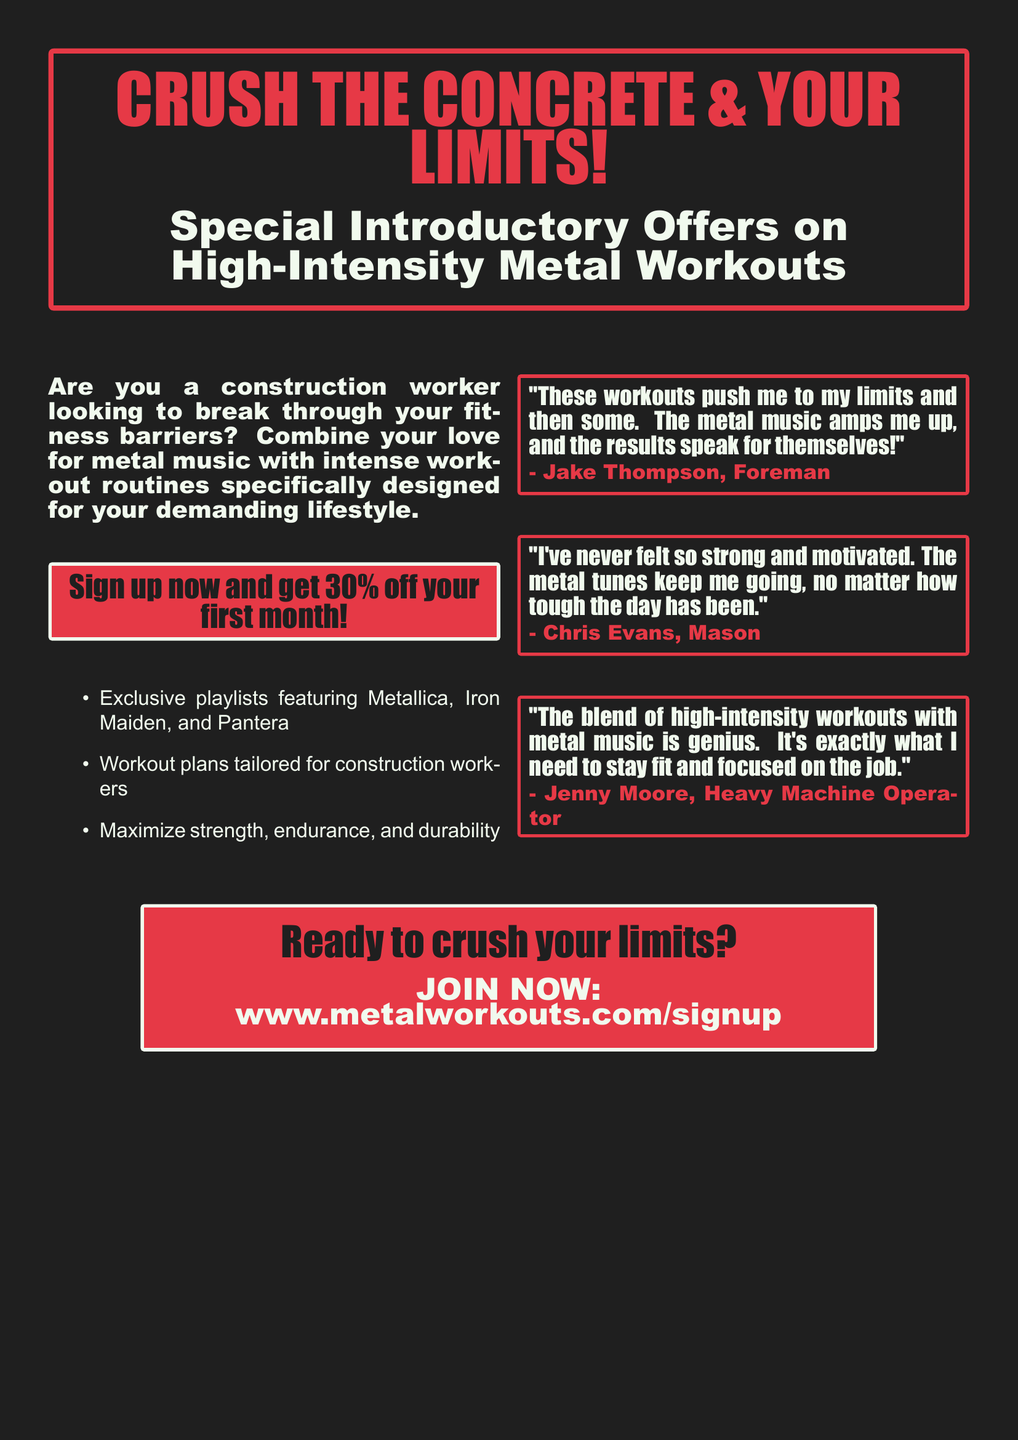What is the discount offered on the first month? The document states that signing up now gets you 30% off your first month.
Answer: 30% Who is the target audience for these workouts? The advertisement mentions construction workers specifically as the audience for the workouts.
Answer: Construction workers Which band is mentioned as part of the exclusive playlists? The document lists Metallica among the bands featured in the playlists.
Answer: Metallica What is the website for sign-up? The advertisement provides the sign-up URL as www.metalworkouts.com/signup.
Answer: www.metalworkouts.com/signup What type of workouts are offered according to the document? The document describes the workouts as high-intensity workouts tailored for construction workers.
Answer: High-intensity workouts What quote does Jake Thompson give about the workouts? Jake Thompson emphasizes that the workouts push him to his limits and that the results speak for themselves.
Answer: "These workouts push me to my limits and then some. The metal music amps me up, and the results speak for themselves!" How does Chris Evans feel about his strength? According to Chris Evans, he has never felt so strong and motivated.
Answer: Strong and motivated What aspect of the workouts does Jenny Moore find appealing? Jenny Moore mentions the combination of high-intensity workouts with metal music as a genius blend.
Answer: Genius blend 